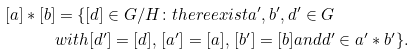Convert formula to latex. <formula><loc_0><loc_0><loc_500><loc_500>[ a ] \ast [ b ] & = \{ [ d ] \in G / H \colon t h e r e e x i s t a ^ { \prime } , b ^ { \prime } , d ^ { \prime } \in G \\ & w i t h [ d ^ { \prime } ] = [ d ] , \, [ a ^ { \prime } ] = [ a ] , \, [ b ^ { \prime } ] = [ b ] a n d d ^ { \prime } \in a ^ { \prime } \ast b ^ { \prime } \} .</formula> 